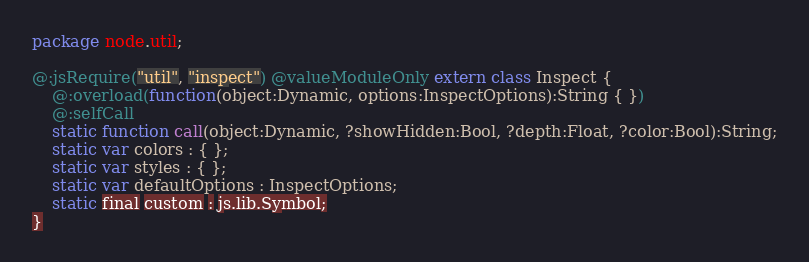<code> <loc_0><loc_0><loc_500><loc_500><_Haxe_>package node.util;

@:jsRequire("util", "inspect") @valueModuleOnly extern class Inspect {
	@:overload(function(object:Dynamic, options:InspectOptions):String { })
	@:selfCall
	static function call(object:Dynamic, ?showHidden:Bool, ?depth:Float, ?color:Bool):String;
	static var colors : { };
	static var styles : { };
	static var defaultOptions : InspectOptions;
	static final custom : js.lib.Symbol;
}</code> 